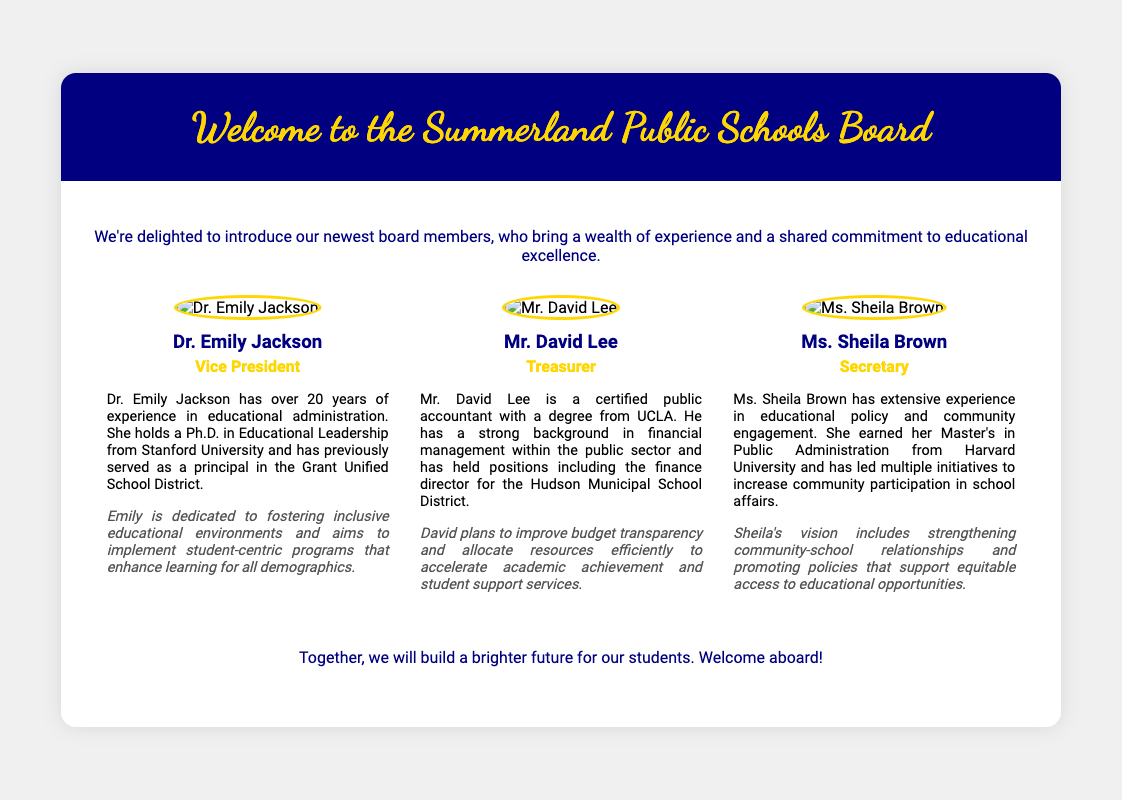What is the title of the card? The title of the card is prominently displayed in the header section of the document.
Answer: Welcome to the Summerland Public Schools Board Who is the Vice President? The document lists the complete names and titles of the new board members.
Answer: Dr. Emily Jackson What degree does Mr. David Lee have? The bio of Mr. David Lee specifies his educational background.
Answer: UCLA What is Sheila Brown's vision? The document highlights each member's vision statement after their bio.
Answer: Strengthening community-school relationships and promoting equitable access How many members are introduced in the card? The card presents individual sections for each new board member, allowing for counting.
Answer: Three What color is the card's header? The header's background color is specified in the style section of the document.
Answer: Navy What is the primary theme of the introductory paragraph? The introductory paragraph summarizes the intent behind the introduction of new board members.
Answer: Delighted to introduce What type of document is this? The structure and content of the document indicate its purpose.
Answer: Greeting card 